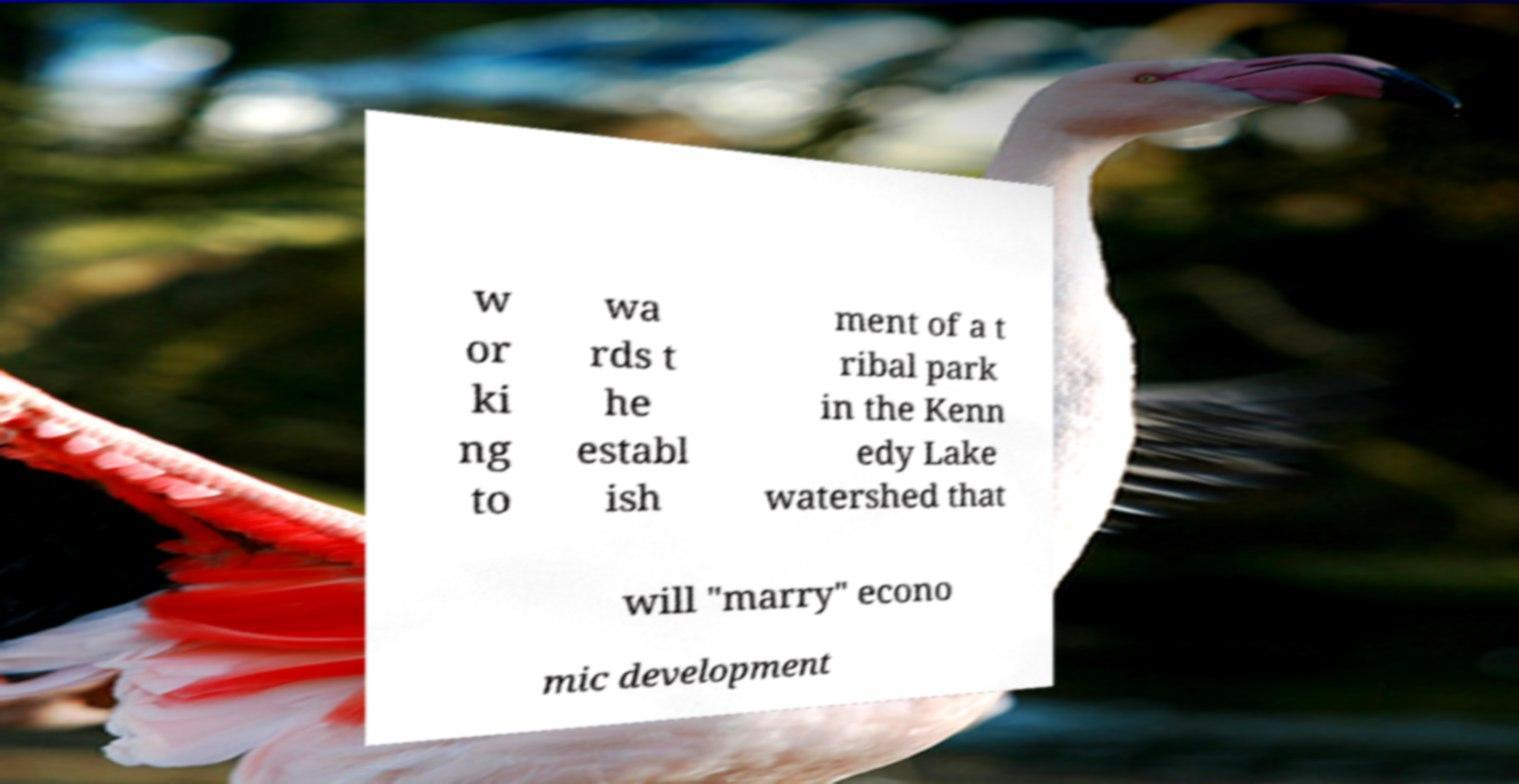Please read and relay the text visible in this image. What does it say? w or ki ng to wa rds t he establ ish ment of a t ribal park in the Kenn edy Lake watershed that will "marry" econo mic development 